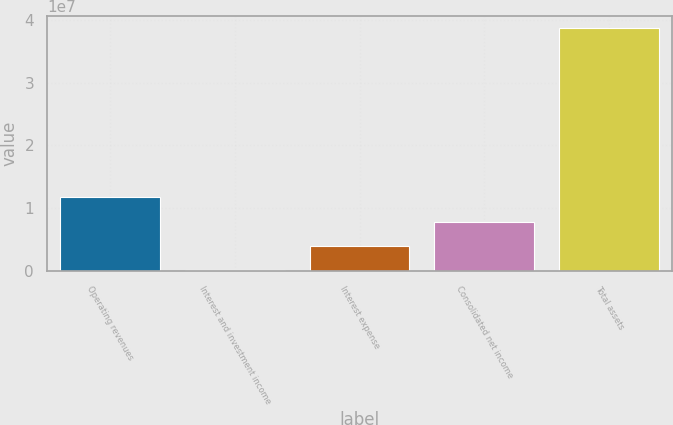<chart> <loc_0><loc_0><loc_500><loc_500><bar_chart><fcel>Operating revenues<fcel>Interest and investment income<fcel>Interest expense<fcel>Consolidated net income<fcel>Total assets<nl><fcel>1.17354e+07<fcel>185455<fcel>4.03544e+06<fcel>7.88542e+06<fcel>3.86853e+07<nl></chart> 